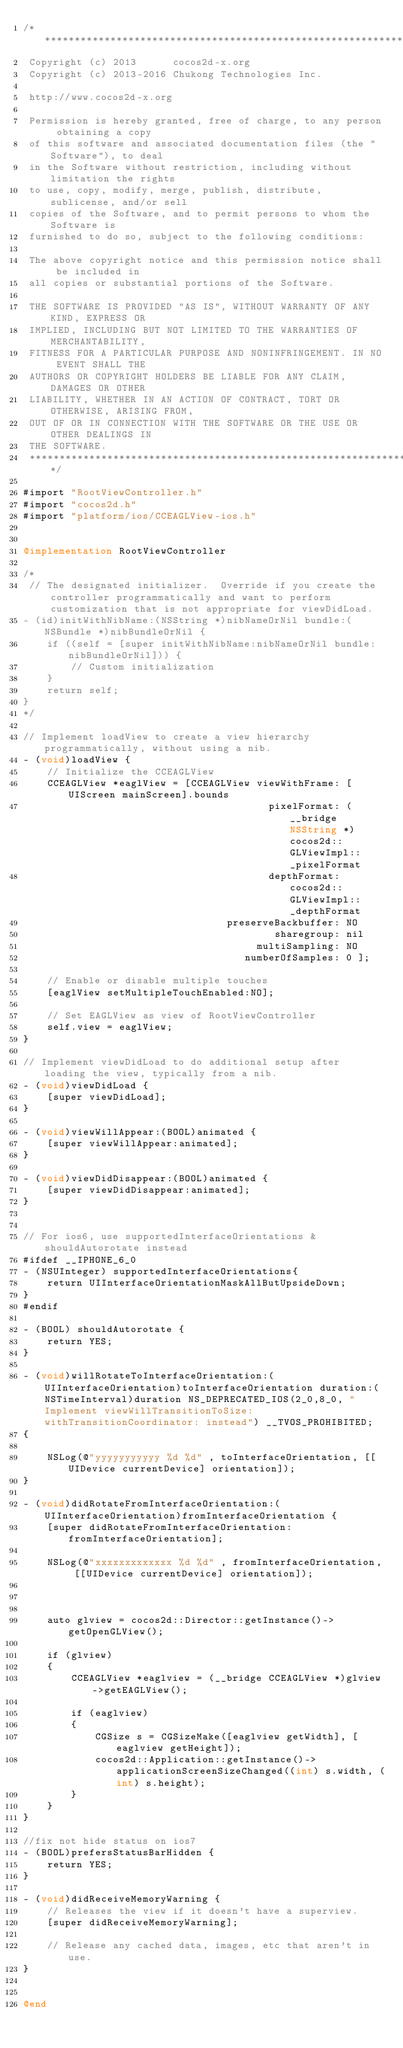Convert code to text. <code><loc_0><loc_0><loc_500><loc_500><_ObjectiveC_>/****************************************************************************
 Copyright (c) 2013      cocos2d-x.org
 Copyright (c) 2013-2016 Chukong Technologies Inc.

 http://www.cocos2d-x.org

 Permission is hereby granted, free of charge, to any person obtaining a copy
 of this software and associated documentation files (the "Software"), to deal
 in the Software without restriction, including without limitation the rights
 to use, copy, modify, merge, publish, distribute, sublicense, and/or sell
 copies of the Software, and to permit persons to whom the Software is
 furnished to do so, subject to the following conditions:

 The above copyright notice and this permission notice shall be included in
 all copies or substantial portions of the Software.

 THE SOFTWARE IS PROVIDED "AS IS", WITHOUT WARRANTY OF ANY KIND, EXPRESS OR
 IMPLIED, INCLUDING BUT NOT LIMITED TO THE WARRANTIES OF MERCHANTABILITY,
 FITNESS FOR A PARTICULAR PURPOSE AND NONINFRINGEMENT. IN NO EVENT SHALL THE
 AUTHORS OR COPYRIGHT HOLDERS BE LIABLE FOR ANY CLAIM, DAMAGES OR OTHER
 LIABILITY, WHETHER IN AN ACTION OF CONTRACT, TORT OR OTHERWISE, ARISING FROM,
 OUT OF OR IN CONNECTION WITH THE SOFTWARE OR THE USE OR OTHER DEALINGS IN
 THE SOFTWARE.
 ****************************************************************************/

#import "RootViewController.h"
#import "cocos2d.h"
#import "platform/ios/CCEAGLView-ios.h"


@implementation RootViewController

/*
 // The designated initializer.  Override if you create the controller programmatically and want to perform customization that is not appropriate for viewDidLoad.
- (id)initWithNibName:(NSString *)nibNameOrNil bundle:(NSBundle *)nibBundleOrNil {
    if ((self = [super initWithNibName:nibNameOrNil bundle:nibBundleOrNil])) {
        // Custom initialization
    }
    return self;
}
*/

// Implement loadView to create a view hierarchy programmatically, without using a nib.
- (void)loadView {
    // Initialize the CCEAGLView
    CCEAGLView *eaglView = [CCEAGLView viewWithFrame: [UIScreen mainScreen].bounds
                                         pixelFormat: (__bridge NSString *)cocos2d::GLViewImpl::_pixelFormat
                                         depthFormat: cocos2d::GLViewImpl::_depthFormat
                                  preserveBackbuffer: NO
                                          sharegroup: nil
                                       multiSampling: NO
                                     numberOfSamples: 0 ];
    
    // Enable or disable multiple touches
    [eaglView setMultipleTouchEnabled:NO];
    
    // Set EAGLView as view of RootViewController
    self.view = eaglView;
}

// Implement viewDidLoad to do additional setup after loading the view, typically from a nib.
- (void)viewDidLoad {
    [super viewDidLoad];
}

- (void)viewWillAppear:(BOOL)animated {
    [super viewWillAppear:animated];
}

- (void)viewDidDisappear:(BOOL)animated {
    [super viewDidDisappear:animated];
}


// For ios6, use supportedInterfaceOrientations & shouldAutorotate instead
#ifdef __IPHONE_6_0
- (NSUInteger) supportedInterfaceOrientations{
    return UIInterfaceOrientationMaskAllButUpsideDown;
}
#endif

- (BOOL) shouldAutorotate {
    return YES;
}

- (void)willRotateToInterfaceOrientation:(UIInterfaceOrientation)toInterfaceOrientation duration:(NSTimeInterval)duration NS_DEPRECATED_IOS(2_0,8_0, "Implement viewWillTransitionToSize:withTransitionCoordinator: instead") __TVOS_PROHIBITED;
{
    
    NSLog(@"yyyyyyyyyyy %d %d" , toInterfaceOrientation, [[UIDevice currentDevice] orientation]);
}

- (void)didRotateFromInterfaceOrientation:(UIInterfaceOrientation)fromInterfaceOrientation {
    [super didRotateFromInterfaceOrientation:fromInterfaceOrientation];
    
    NSLog(@"xxxxxxxxxxxxx %d %d" , fromInterfaceOrientation, [[UIDevice currentDevice] orientation]);
    
    

    auto glview = cocos2d::Director::getInstance()->getOpenGLView();

    if (glview)
    {
        CCEAGLView *eaglview = (__bridge CCEAGLView *)glview->getEAGLView();

        if (eaglview)
        {
            CGSize s = CGSizeMake([eaglview getWidth], [eaglview getHeight]);
            cocos2d::Application::getInstance()->applicationScreenSizeChanged((int) s.width, (int) s.height);
        }
    }
}

//fix not hide status on ios7
- (BOOL)prefersStatusBarHidden {
    return YES;
}

- (void)didReceiveMemoryWarning {
    // Releases the view if it doesn't have a superview.
    [super didReceiveMemoryWarning];

    // Release any cached data, images, etc that aren't in use.
}


@end
</code> 